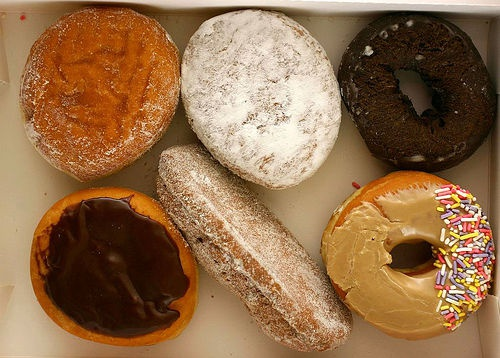Describe the objects in this image and their specific colors. I can see donut in tan, black, brown, maroon, and orange tones, donut in tan, olive, and orange tones, donut in tan and beige tones, donut in tan, brown, and maroon tones, and donut in tan, black, maroon, and gray tones in this image. 